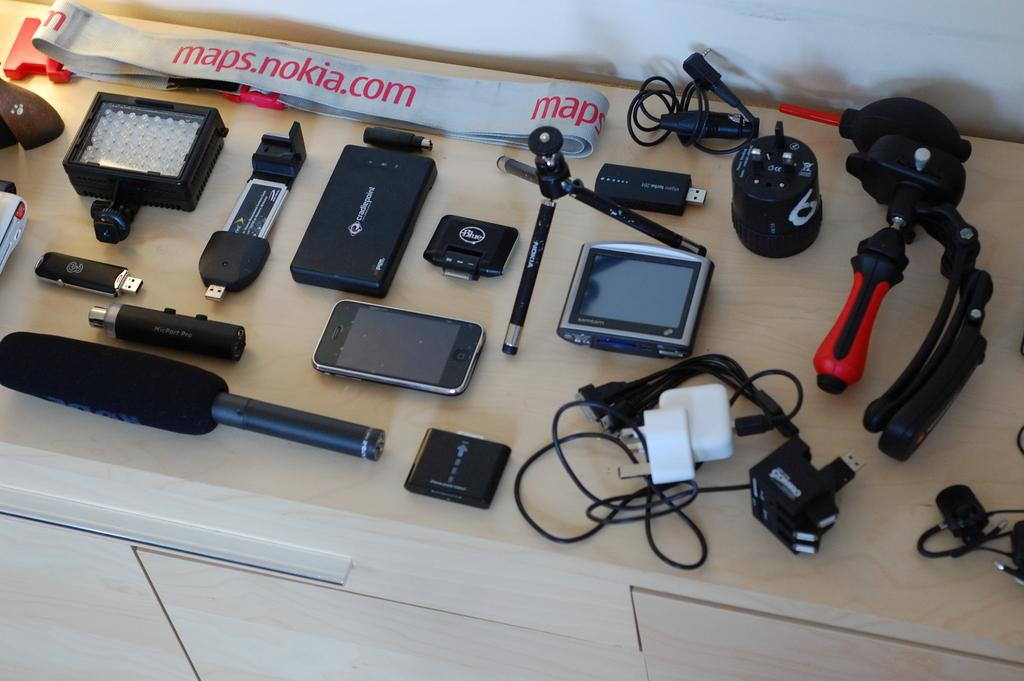Provide a one-sentence caption for the provided image. many tools below a maps.nokia.com site above it. 